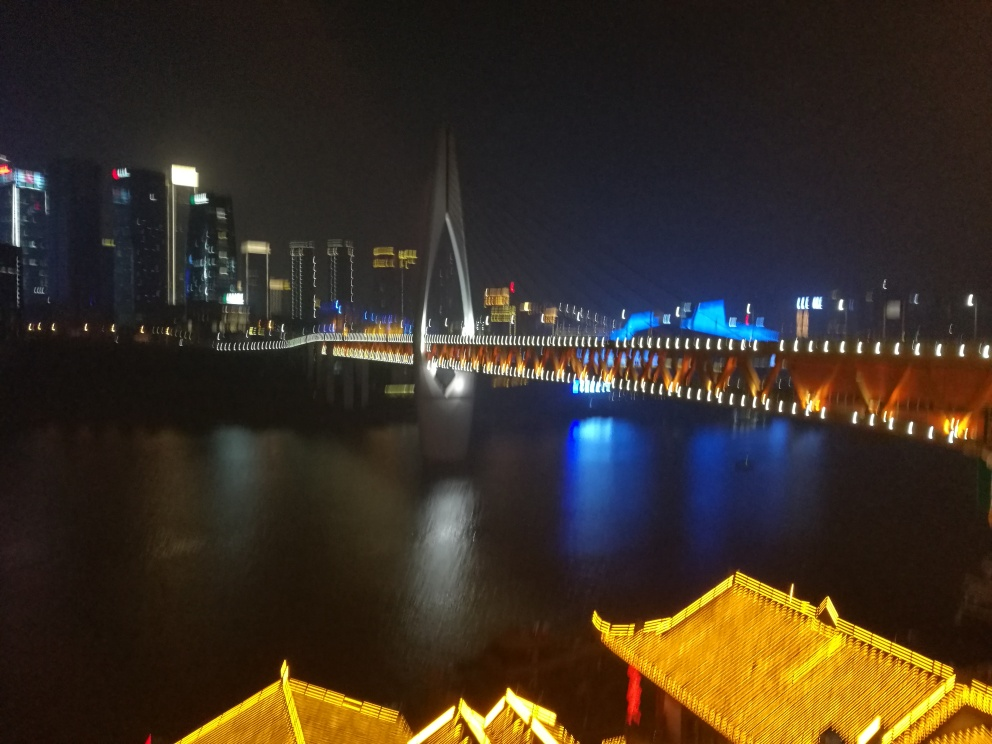What mood does this image convey to you? The image conveys a vibrant and dynamic mood, reflecting the energy of a city at night. The mixture of warm and cool lights creates a sense of activity and life persisting after dark. 